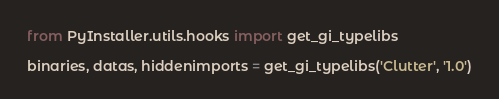<code> <loc_0><loc_0><loc_500><loc_500><_Python_>from PyInstaller.utils.hooks import get_gi_typelibs

binaries, datas, hiddenimports = get_gi_typelibs('Clutter', '1.0')
</code> 